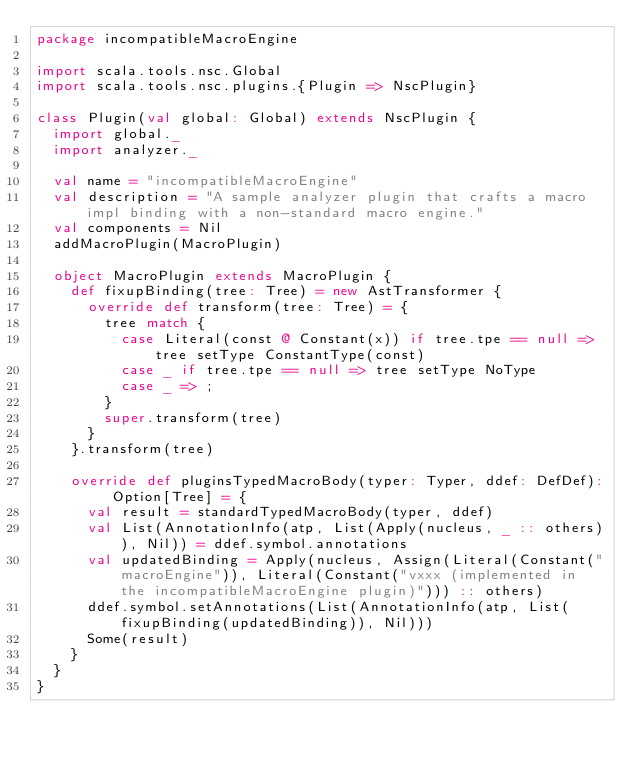Convert code to text. <code><loc_0><loc_0><loc_500><loc_500><_Scala_>package incompatibleMacroEngine

import scala.tools.nsc.Global
import scala.tools.nsc.plugins.{Plugin => NscPlugin}

class Plugin(val global: Global) extends NscPlugin {
  import global._
  import analyzer._

  val name = "incompatibleMacroEngine"
  val description = "A sample analyzer plugin that crafts a macro impl binding with a non-standard macro engine."
  val components = Nil
  addMacroPlugin(MacroPlugin)

  object MacroPlugin extends MacroPlugin {
    def fixupBinding(tree: Tree) = new AstTransformer {
      override def transform(tree: Tree) = {
        tree match {
          case Literal(const @ Constant(x)) if tree.tpe == null => tree setType ConstantType(const)
          case _ if tree.tpe == null => tree setType NoType
          case _ => ;
        }
        super.transform(tree)
      }
    }.transform(tree)

    override def pluginsTypedMacroBody(typer: Typer, ddef: DefDef): Option[Tree] = {
      val result = standardTypedMacroBody(typer, ddef)
      val List(AnnotationInfo(atp, List(Apply(nucleus, _ :: others)), Nil)) = ddef.symbol.annotations
      val updatedBinding = Apply(nucleus, Assign(Literal(Constant("macroEngine")), Literal(Constant("vxxx (implemented in the incompatibleMacroEngine plugin)"))) :: others)
      ddef.symbol.setAnnotations(List(AnnotationInfo(atp, List(fixupBinding(updatedBinding)), Nil)))
      Some(result)
    }
  }
}
</code> 